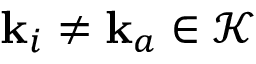<formula> <loc_0><loc_0><loc_500><loc_500>k _ { i } \neq k _ { a } \in \mathcal { K }</formula> 